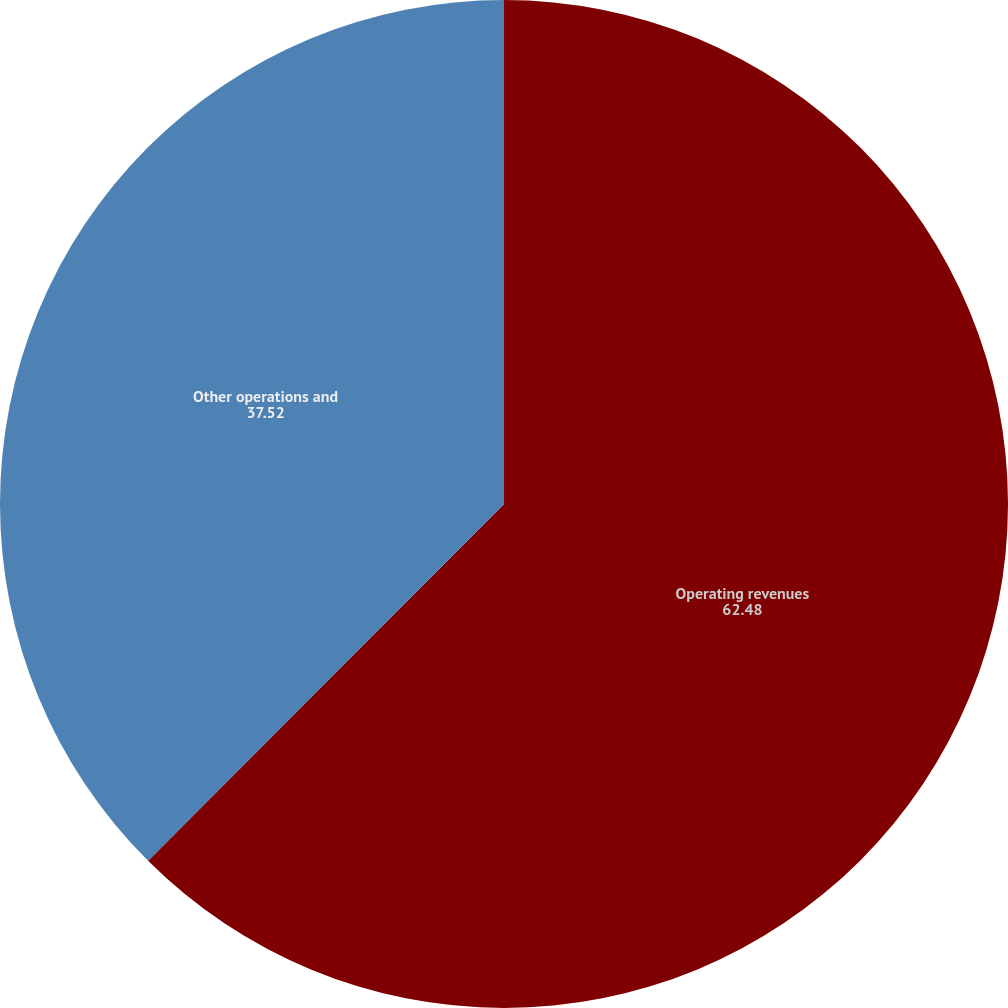Convert chart. <chart><loc_0><loc_0><loc_500><loc_500><pie_chart><fcel>Operating revenues<fcel>Other operations and<nl><fcel>62.48%<fcel>37.52%<nl></chart> 